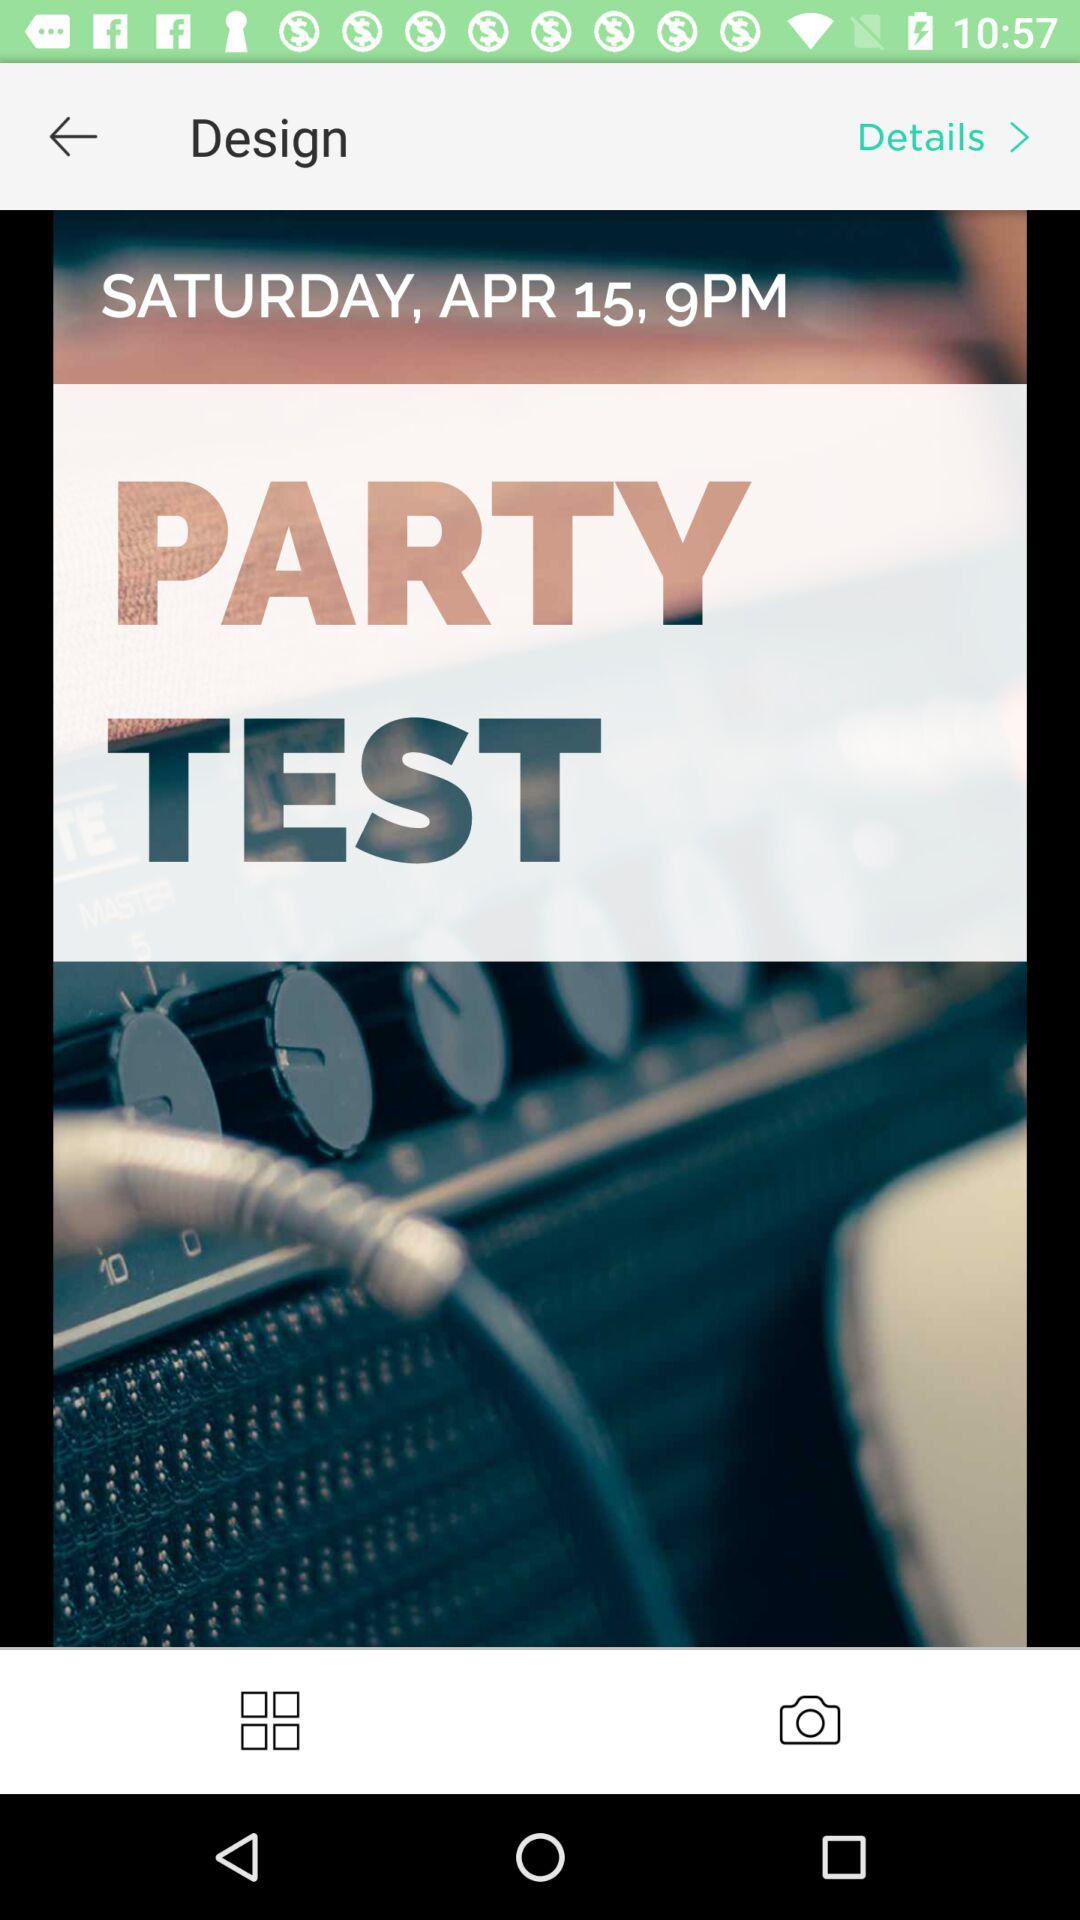What day is shown? The day is Saturday. 